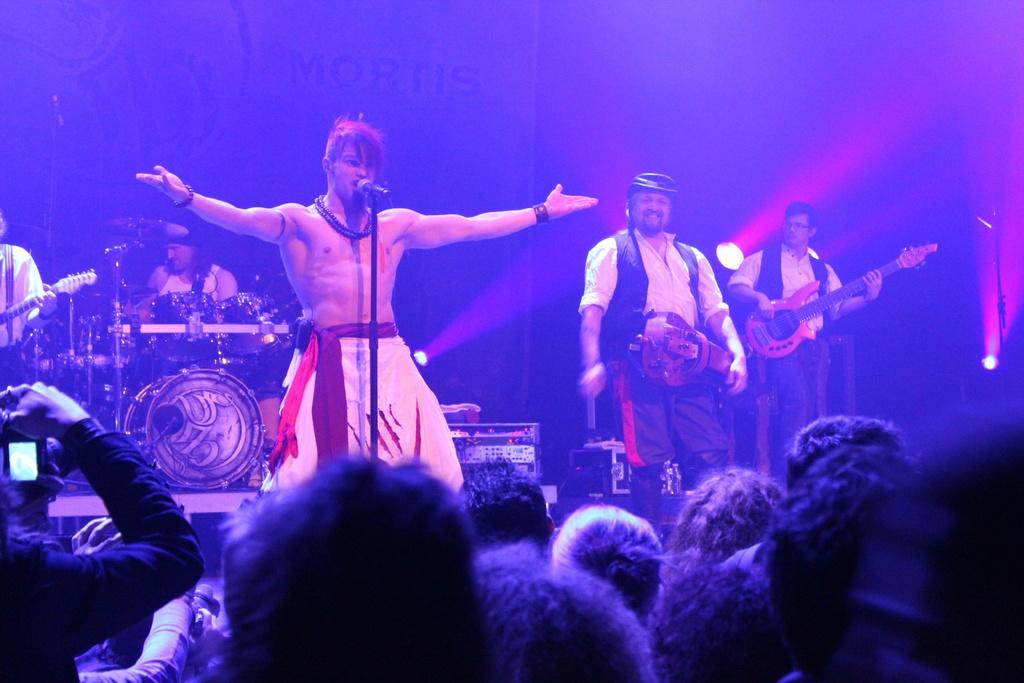What is the shirtless person doing in the image? The shirtless person is singing in the image. What object is the shirtless person using while singing? There is a microphone in the image, which the shirtless person might be using. What is the person wearing a white dress doing in the image? The person wearing a white dress is playing music in the image. Where are the musicians located in the image? The musicians are on a stage in the image. Who is present in front of the stage in the image? There is an audience in front of the stage in the image. What type of string is being used by the governor in the image? There is no governor or string present in the image. What type of bedroom furniture can be seen in the image? There is no bedroom or furniture present in the image; it features musicians on a stage with an audience. 